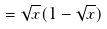Convert formula to latex. <formula><loc_0><loc_0><loc_500><loc_500>= \sqrt { x } ( 1 - \sqrt { x } )</formula> 